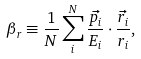<formula> <loc_0><loc_0><loc_500><loc_500>\beta _ { r } \equiv \frac { 1 } { N } \sum _ { i } ^ { N } \frac { \vec { p _ { i } } } { E _ { i } } \cdot \frac { \vec { r _ { i } } } { r _ { i } } ,</formula> 